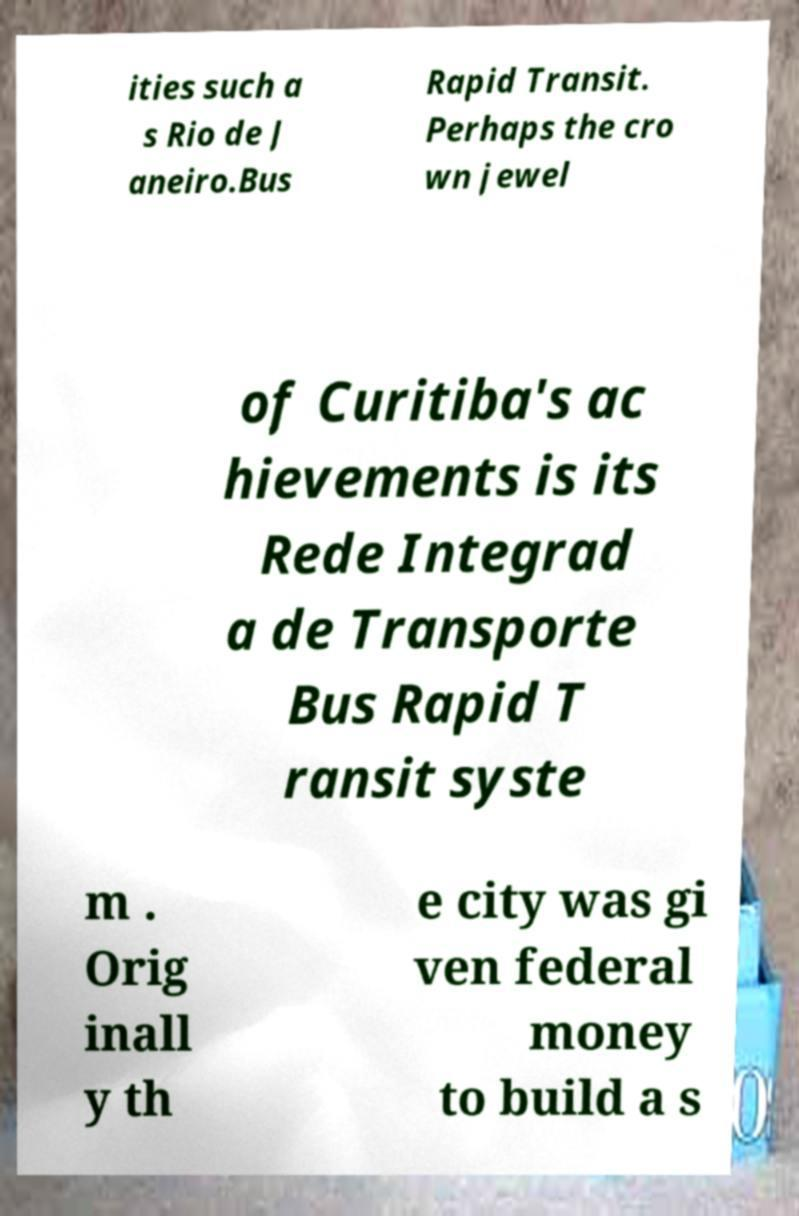Could you assist in decoding the text presented in this image and type it out clearly? ities such a s Rio de J aneiro.Bus Rapid Transit. Perhaps the cro wn jewel of Curitiba's ac hievements is its Rede Integrad a de Transporte Bus Rapid T ransit syste m . Orig inall y th e city was gi ven federal money to build a s 